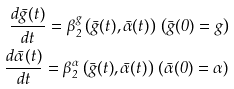Convert formula to latex. <formula><loc_0><loc_0><loc_500><loc_500>\frac { d \bar { g } ( t ) } { d t } = \beta ^ { g } _ { 2 } \left ( \bar { g } ( t ) , \bar { \alpha } ( t ) \right ) \, \left ( \bar { g } ( 0 ) = g \right ) \\ \frac { d \bar { \alpha } ( t ) } { d t } = \beta ^ { \alpha } _ { 2 } \left ( \bar { g } ( t ) , \bar { \alpha } ( t ) \right ) \, \left ( \bar { \alpha } ( 0 ) = \alpha \right )</formula> 